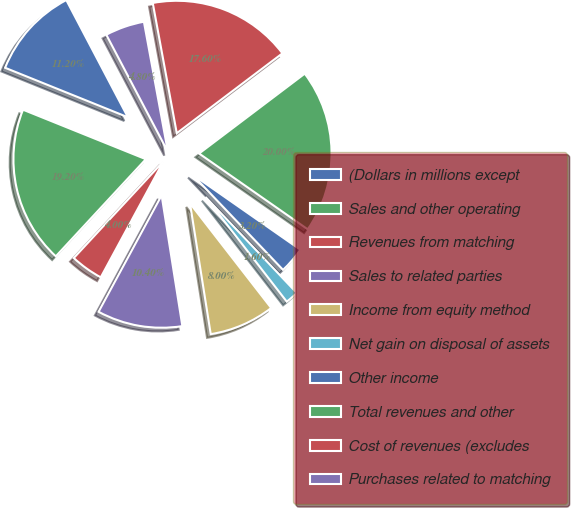Convert chart to OTSL. <chart><loc_0><loc_0><loc_500><loc_500><pie_chart><fcel>(Dollars in millions except<fcel>Sales and other operating<fcel>Revenues from matching<fcel>Sales to related parties<fcel>Income from equity method<fcel>Net gain on disposal of assets<fcel>Other income<fcel>Total revenues and other<fcel>Cost of revenues (excludes<fcel>Purchases related to matching<nl><fcel>11.2%<fcel>19.2%<fcel>4.0%<fcel>10.4%<fcel>8.0%<fcel>1.6%<fcel>3.2%<fcel>20.0%<fcel>17.6%<fcel>4.8%<nl></chart> 